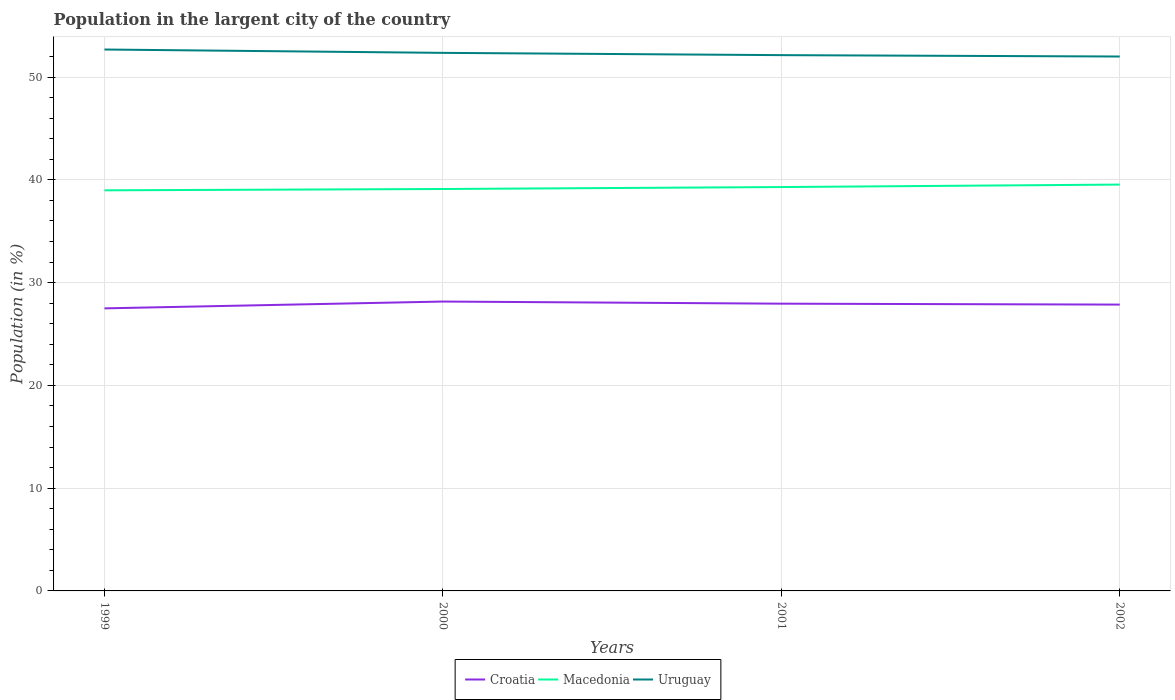How many different coloured lines are there?
Give a very brief answer. 3. Does the line corresponding to Croatia intersect with the line corresponding to Macedonia?
Give a very brief answer. No. Is the number of lines equal to the number of legend labels?
Make the answer very short. Yes. Across all years, what is the maximum percentage of population in the largent city in Macedonia?
Make the answer very short. 38.98. In which year was the percentage of population in the largent city in Macedonia maximum?
Your response must be concise. 1999. What is the total percentage of population in the largent city in Uruguay in the graph?
Provide a succinct answer. 0.13. What is the difference between the highest and the second highest percentage of population in the largent city in Macedonia?
Ensure brevity in your answer.  0.56. How many years are there in the graph?
Give a very brief answer. 4. Are the values on the major ticks of Y-axis written in scientific E-notation?
Offer a very short reply. No. Where does the legend appear in the graph?
Offer a very short reply. Bottom center. What is the title of the graph?
Keep it short and to the point. Population in the largent city of the country. Does "Haiti" appear as one of the legend labels in the graph?
Give a very brief answer. No. What is the label or title of the Y-axis?
Your answer should be compact. Population (in %). What is the Population (in %) in Croatia in 1999?
Ensure brevity in your answer.  27.5. What is the Population (in %) of Macedonia in 1999?
Offer a terse response. 38.98. What is the Population (in %) in Uruguay in 1999?
Your response must be concise. 52.69. What is the Population (in %) of Croatia in 2000?
Keep it short and to the point. 28.16. What is the Population (in %) of Macedonia in 2000?
Your answer should be very brief. 39.11. What is the Population (in %) of Uruguay in 2000?
Provide a succinct answer. 52.36. What is the Population (in %) in Croatia in 2001?
Make the answer very short. 27.95. What is the Population (in %) of Macedonia in 2001?
Make the answer very short. 39.3. What is the Population (in %) in Uruguay in 2001?
Offer a terse response. 52.14. What is the Population (in %) in Croatia in 2002?
Ensure brevity in your answer.  27.86. What is the Population (in %) of Macedonia in 2002?
Your response must be concise. 39.54. What is the Population (in %) of Uruguay in 2002?
Give a very brief answer. 52. Across all years, what is the maximum Population (in %) of Croatia?
Ensure brevity in your answer.  28.16. Across all years, what is the maximum Population (in %) in Macedonia?
Your response must be concise. 39.54. Across all years, what is the maximum Population (in %) in Uruguay?
Offer a terse response. 52.69. Across all years, what is the minimum Population (in %) in Croatia?
Your answer should be very brief. 27.5. Across all years, what is the minimum Population (in %) in Macedonia?
Your answer should be very brief. 38.98. Across all years, what is the minimum Population (in %) in Uruguay?
Keep it short and to the point. 52. What is the total Population (in %) of Croatia in the graph?
Give a very brief answer. 111.48. What is the total Population (in %) of Macedonia in the graph?
Offer a terse response. 156.94. What is the total Population (in %) in Uruguay in the graph?
Give a very brief answer. 209.19. What is the difference between the Population (in %) of Croatia in 1999 and that in 2000?
Ensure brevity in your answer.  -0.66. What is the difference between the Population (in %) of Macedonia in 1999 and that in 2000?
Provide a succinct answer. -0.13. What is the difference between the Population (in %) of Uruguay in 1999 and that in 2000?
Ensure brevity in your answer.  0.33. What is the difference between the Population (in %) of Croatia in 1999 and that in 2001?
Offer a very short reply. -0.46. What is the difference between the Population (in %) of Macedonia in 1999 and that in 2001?
Give a very brief answer. -0.32. What is the difference between the Population (in %) of Uruguay in 1999 and that in 2001?
Your answer should be compact. 0.55. What is the difference between the Population (in %) in Croatia in 1999 and that in 2002?
Offer a terse response. -0.37. What is the difference between the Population (in %) in Macedonia in 1999 and that in 2002?
Your response must be concise. -0.56. What is the difference between the Population (in %) in Uruguay in 1999 and that in 2002?
Provide a short and direct response. 0.68. What is the difference between the Population (in %) of Croatia in 2000 and that in 2001?
Ensure brevity in your answer.  0.21. What is the difference between the Population (in %) in Macedonia in 2000 and that in 2001?
Keep it short and to the point. -0.19. What is the difference between the Population (in %) of Uruguay in 2000 and that in 2001?
Your answer should be compact. 0.22. What is the difference between the Population (in %) of Croatia in 2000 and that in 2002?
Ensure brevity in your answer.  0.3. What is the difference between the Population (in %) of Macedonia in 2000 and that in 2002?
Provide a short and direct response. -0.43. What is the difference between the Population (in %) in Uruguay in 2000 and that in 2002?
Offer a terse response. 0.36. What is the difference between the Population (in %) in Croatia in 2001 and that in 2002?
Give a very brief answer. 0.09. What is the difference between the Population (in %) of Macedonia in 2001 and that in 2002?
Make the answer very short. -0.24. What is the difference between the Population (in %) of Uruguay in 2001 and that in 2002?
Offer a terse response. 0.13. What is the difference between the Population (in %) in Croatia in 1999 and the Population (in %) in Macedonia in 2000?
Offer a terse response. -11.61. What is the difference between the Population (in %) of Croatia in 1999 and the Population (in %) of Uruguay in 2000?
Ensure brevity in your answer.  -24.86. What is the difference between the Population (in %) in Macedonia in 1999 and the Population (in %) in Uruguay in 2000?
Your response must be concise. -13.38. What is the difference between the Population (in %) in Croatia in 1999 and the Population (in %) in Macedonia in 2001?
Ensure brevity in your answer.  -11.81. What is the difference between the Population (in %) of Croatia in 1999 and the Population (in %) of Uruguay in 2001?
Offer a terse response. -24.64. What is the difference between the Population (in %) in Macedonia in 1999 and the Population (in %) in Uruguay in 2001?
Your answer should be compact. -13.15. What is the difference between the Population (in %) in Croatia in 1999 and the Population (in %) in Macedonia in 2002?
Your answer should be very brief. -12.05. What is the difference between the Population (in %) in Croatia in 1999 and the Population (in %) in Uruguay in 2002?
Provide a short and direct response. -24.51. What is the difference between the Population (in %) of Macedonia in 1999 and the Population (in %) of Uruguay in 2002?
Your answer should be compact. -13.02. What is the difference between the Population (in %) in Croatia in 2000 and the Population (in %) in Macedonia in 2001?
Give a very brief answer. -11.14. What is the difference between the Population (in %) in Croatia in 2000 and the Population (in %) in Uruguay in 2001?
Make the answer very short. -23.98. What is the difference between the Population (in %) of Macedonia in 2000 and the Population (in %) of Uruguay in 2001?
Your response must be concise. -13.03. What is the difference between the Population (in %) of Croatia in 2000 and the Population (in %) of Macedonia in 2002?
Offer a terse response. -11.38. What is the difference between the Population (in %) in Croatia in 2000 and the Population (in %) in Uruguay in 2002?
Your response must be concise. -23.84. What is the difference between the Population (in %) in Macedonia in 2000 and the Population (in %) in Uruguay in 2002?
Your response must be concise. -12.89. What is the difference between the Population (in %) of Croatia in 2001 and the Population (in %) of Macedonia in 2002?
Offer a very short reply. -11.59. What is the difference between the Population (in %) in Croatia in 2001 and the Population (in %) in Uruguay in 2002?
Ensure brevity in your answer.  -24.05. What is the difference between the Population (in %) of Macedonia in 2001 and the Population (in %) of Uruguay in 2002?
Make the answer very short. -12.7. What is the average Population (in %) of Croatia per year?
Ensure brevity in your answer.  27.87. What is the average Population (in %) of Macedonia per year?
Your response must be concise. 39.24. What is the average Population (in %) in Uruguay per year?
Give a very brief answer. 52.3. In the year 1999, what is the difference between the Population (in %) of Croatia and Population (in %) of Macedonia?
Give a very brief answer. -11.49. In the year 1999, what is the difference between the Population (in %) in Croatia and Population (in %) in Uruguay?
Keep it short and to the point. -25.19. In the year 1999, what is the difference between the Population (in %) in Macedonia and Population (in %) in Uruguay?
Your answer should be very brief. -13.7. In the year 2000, what is the difference between the Population (in %) in Croatia and Population (in %) in Macedonia?
Your response must be concise. -10.95. In the year 2000, what is the difference between the Population (in %) in Croatia and Population (in %) in Uruguay?
Ensure brevity in your answer.  -24.2. In the year 2000, what is the difference between the Population (in %) of Macedonia and Population (in %) of Uruguay?
Keep it short and to the point. -13.25. In the year 2001, what is the difference between the Population (in %) in Croatia and Population (in %) in Macedonia?
Your answer should be compact. -11.35. In the year 2001, what is the difference between the Population (in %) in Croatia and Population (in %) in Uruguay?
Provide a short and direct response. -24.18. In the year 2001, what is the difference between the Population (in %) in Macedonia and Population (in %) in Uruguay?
Offer a very short reply. -12.84. In the year 2002, what is the difference between the Population (in %) in Croatia and Population (in %) in Macedonia?
Offer a very short reply. -11.68. In the year 2002, what is the difference between the Population (in %) of Croatia and Population (in %) of Uruguay?
Provide a succinct answer. -24.14. In the year 2002, what is the difference between the Population (in %) of Macedonia and Population (in %) of Uruguay?
Ensure brevity in your answer.  -12.46. What is the ratio of the Population (in %) in Croatia in 1999 to that in 2000?
Your answer should be very brief. 0.98. What is the ratio of the Population (in %) in Macedonia in 1999 to that in 2000?
Keep it short and to the point. 1. What is the ratio of the Population (in %) in Croatia in 1999 to that in 2001?
Offer a terse response. 0.98. What is the ratio of the Population (in %) in Uruguay in 1999 to that in 2001?
Your response must be concise. 1.01. What is the ratio of the Population (in %) of Macedonia in 1999 to that in 2002?
Offer a terse response. 0.99. What is the ratio of the Population (in %) of Uruguay in 1999 to that in 2002?
Provide a succinct answer. 1.01. What is the ratio of the Population (in %) of Croatia in 2000 to that in 2001?
Provide a succinct answer. 1.01. What is the ratio of the Population (in %) of Croatia in 2000 to that in 2002?
Provide a short and direct response. 1.01. What is the ratio of the Population (in %) of Uruguay in 2000 to that in 2002?
Offer a terse response. 1.01. What is the ratio of the Population (in %) in Macedonia in 2001 to that in 2002?
Make the answer very short. 0.99. What is the difference between the highest and the second highest Population (in %) in Croatia?
Your response must be concise. 0.21. What is the difference between the highest and the second highest Population (in %) in Macedonia?
Offer a very short reply. 0.24. What is the difference between the highest and the second highest Population (in %) in Uruguay?
Give a very brief answer. 0.33. What is the difference between the highest and the lowest Population (in %) of Croatia?
Your response must be concise. 0.66. What is the difference between the highest and the lowest Population (in %) of Macedonia?
Provide a succinct answer. 0.56. What is the difference between the highest and the lowest Population (in %) in Uruguay?
Provide a short and direct response. 0.68. 